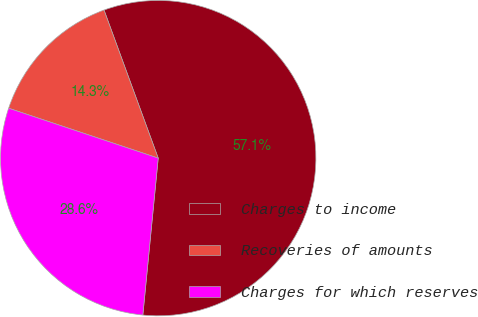Convert chart to OTSL. <chart><loc_0><loc_0><loc_500><loc_500><pie_chart><fcel>Charges to income<fcel>Recoveries of amounts<fcel>Charges for which reserves<nl><fcel>57.14%<fcel>14.29%<fcel>28.57%<nl></chart> 